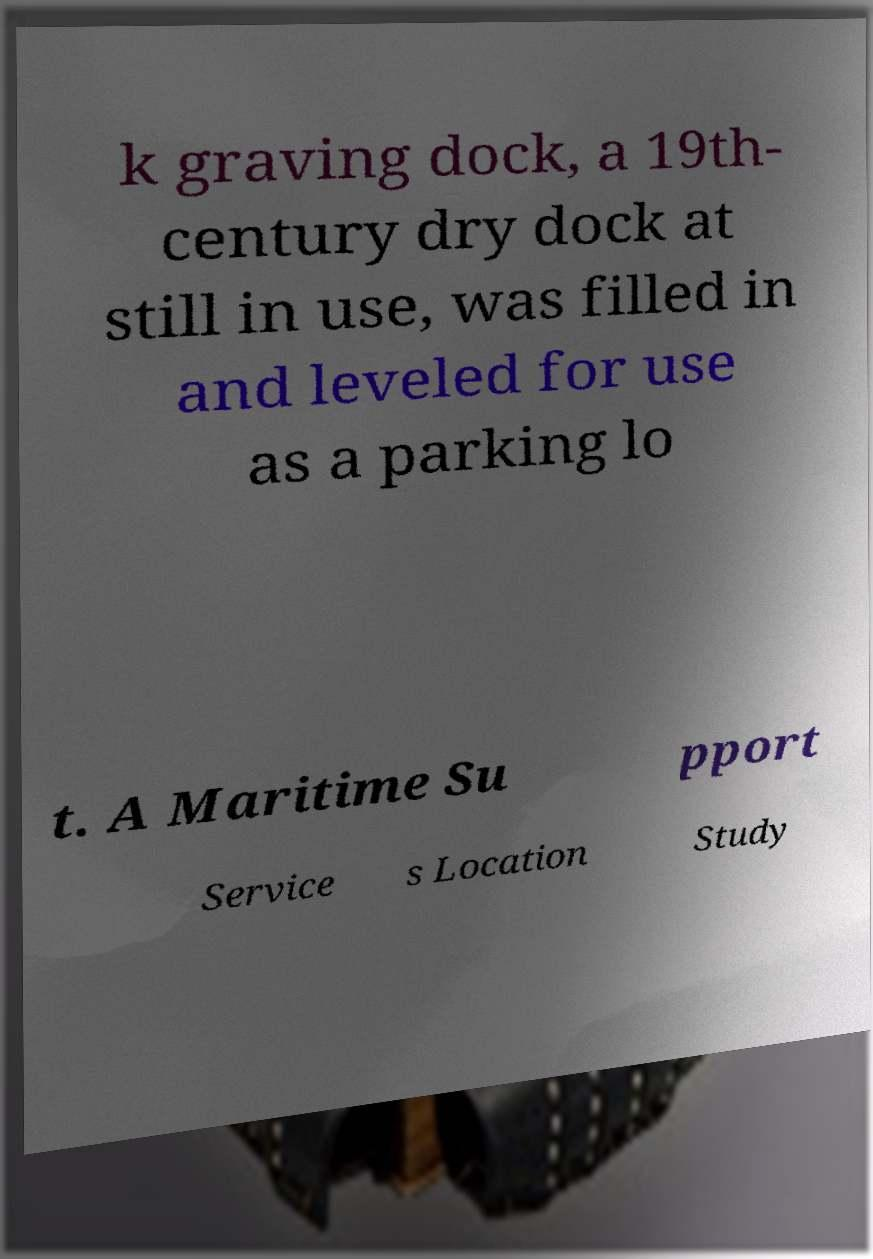There's text embedded in this image that I need extracted. Can you transcribe it verbatim? k graving dock, a 19th- century dry dock at still in use, was filled in and leveled for use as a parking lo t. A Maritime Su pport Service s Location Study 